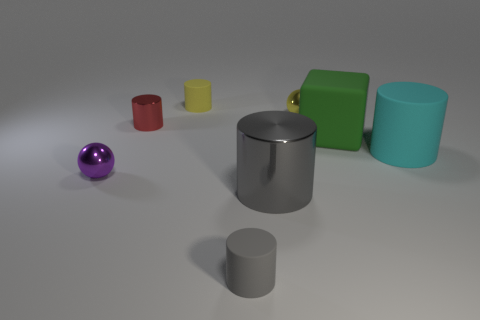How many objects are there in total, and could you describe their shapes and colors? There are six objects in the image, each with a distinct shape and color. Starting from the left, we have a purple metallic sphere, a small red cylinder, a medium yellow cylinder, a large silver cylinder with a reflective surface, a green matte cube, and finally, a large teal cylinder. 